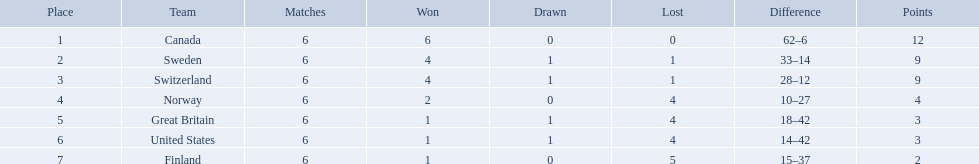What are the titles of the countries? Canada, Sweden, Switzerland, Norway, Great Britain, United States, Finland. How many wins did switzerland attain? 4. How many victories did great britain achieve? 1. Which nation had more triumphs, great britain or switzerland? Switzerland. What are all the team names? Canada, Sweden, Switzerland, Norway, Great Britain, United States, Finland. What were their point totals? 12, 9, 9, 4, 3, 3, 2. What about just considering switzerland and great britain? 9, 3. Can you give me this table as a dict? {'header': ['Place', 'Team', 'Matches', 'Won', 'Drawn', 'Lost', 'Difference', 'Points'], 'rows': [['1', 'Canada', '6', '6', '0', '0', '62–6', '12'], ['2', 'Sweden', '6', '4', '1', '1', '33–14', '9'], ['3', 'Switzerland', '6', '4', '1', '1', '28–12', '9'], ['4', 'Norway', '6', '2', '0', '4', '10–27', '4'], ['5', 'Great Britain', '6', '1', '1', '4', '18–42', '3'], ['6', 'United States', '6', '1', '1', '4', '14–42', '3'], ['7', 'Finland', '6', '1', '0', '5', '15–37', '2']]} Now, which of those teams scored better? Switzerland. What are the names of the two nations? Switzerland, Great Britain. What were their respective point scores? 9, 3. Among these scores, which one is higher? 9. Which nation achieved this higher score? Switzerland. Can you identify the two countries involved? Switzerland, Great Britain. What were their individual point totals? 9, 3. Which of these totals is superior? 9. Which country secured this superior total? Switzerland. Which two countries are being referred to? Switzerland, Great Britain. What were their individual point tallies? 9, 3. Out of these tallies, which one is more favorable? 9. Which country obtained this more favorable tally? Switzerland. 